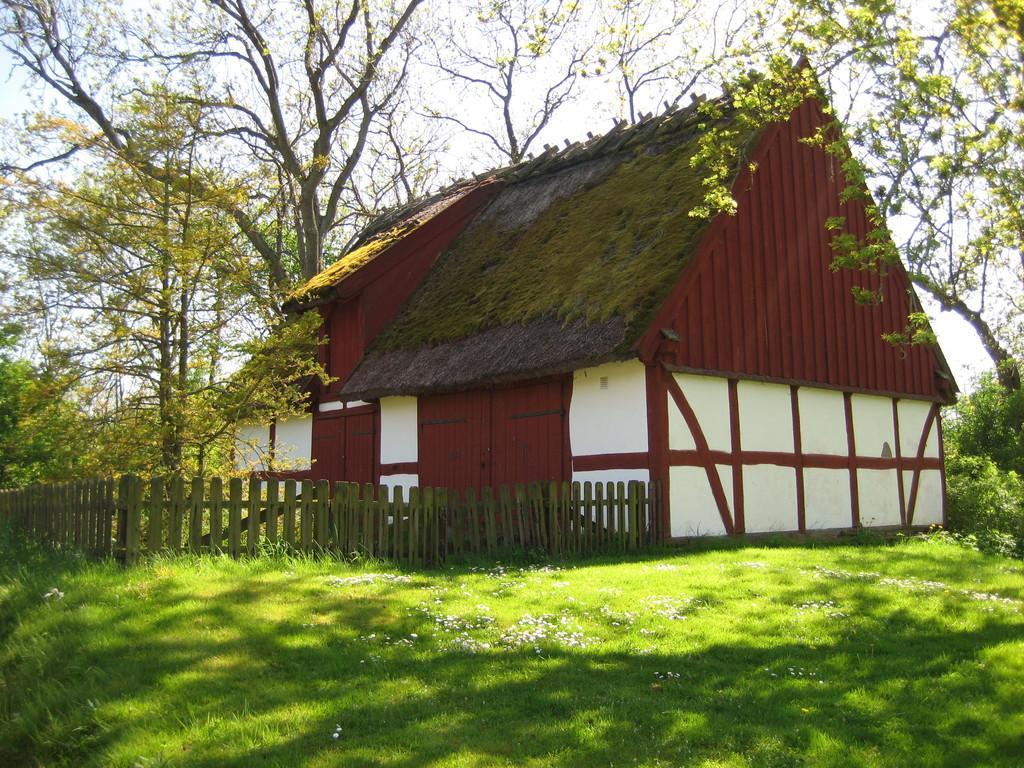Please provide a concise description of this image. In this image there is a hut with wooden fencing. There is grass. There are trees. There is a sky. 